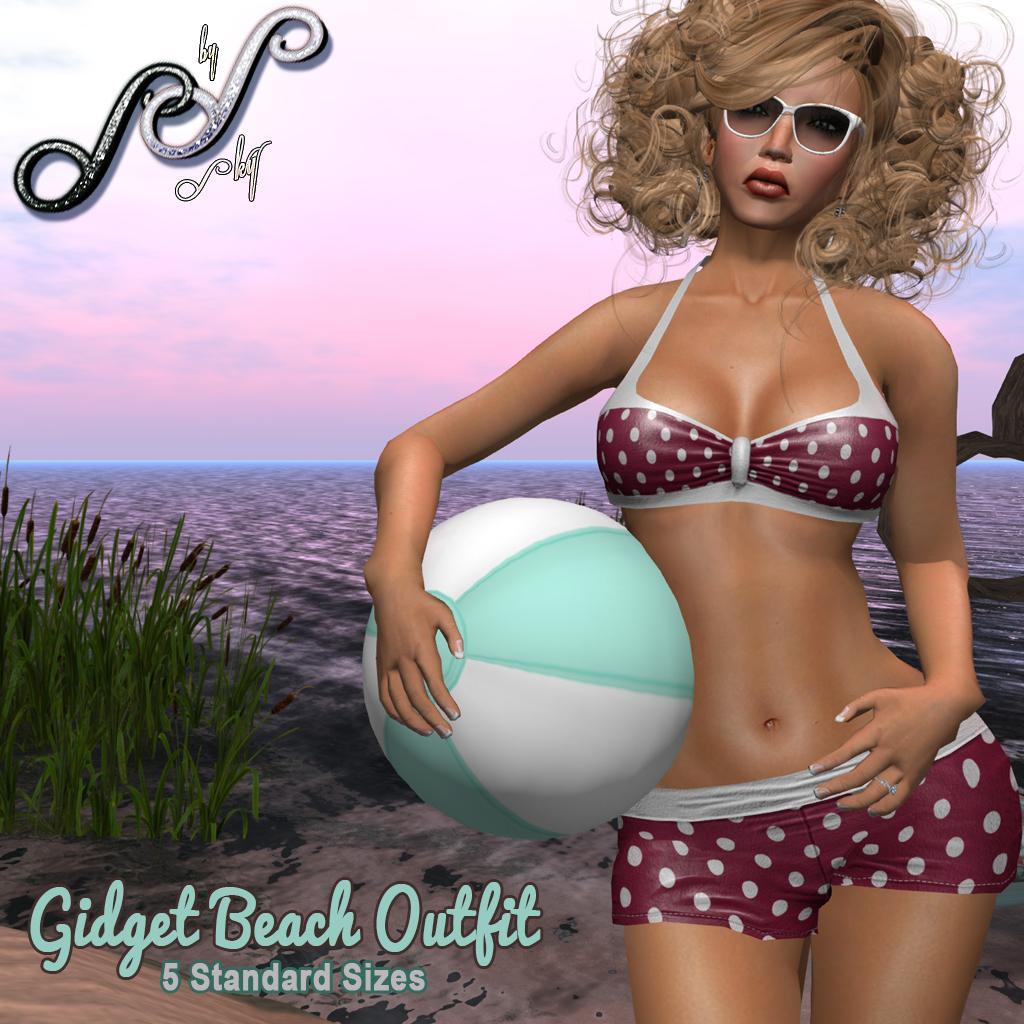Could you give a brief overview of what you see in this image? In this image we can see a cartoon picture of a lady holding a ball, there we can see few a ocean, sand, few plants, the sky and some text on the image. 